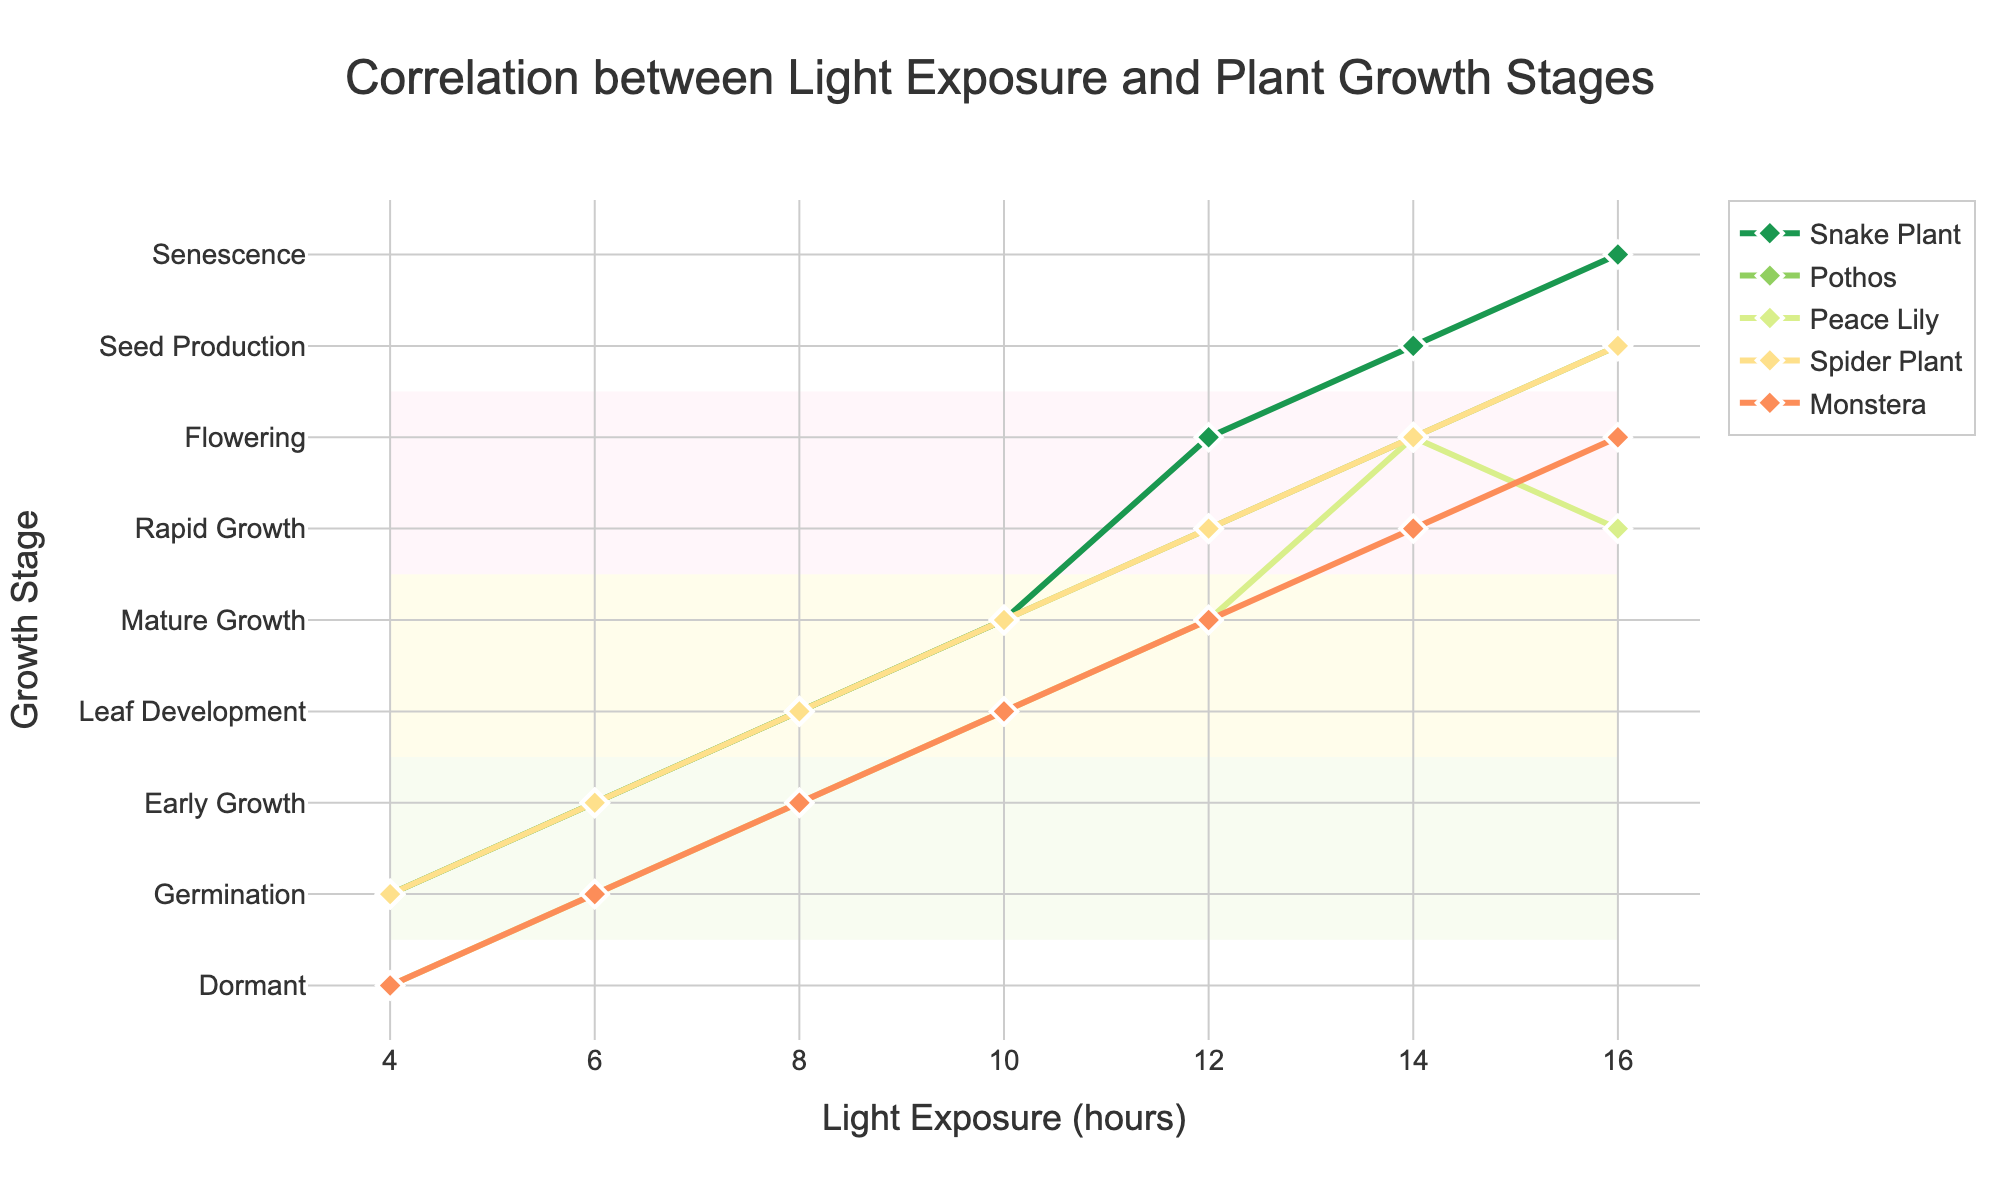What is the growth stage of the Snake Plant at 10 hours of light exposure? Refer to the line representing the Snake Plant at the 10-hour mark on the x-axis. The y-coordinate corresponds to "Mature Growth".
Answer: Mature Growth Which plant reached the "Flowering" stage first? Compare the light exposure durations where each plant reaches the "Flowering" stage. The Pothos reaches "Flowering" at 12 hours, ahead of other plants.
Answer: Pothos Between Snake Plant and Peace Lily, which plant reaches the "Seed Production" stage first? Check the light exposure duration at which both plants reach the "Seed Production" stage. The Snake Plant reaches it at 14 hours, while Peace Lily never reaches this stage.
Answer: Snake Plant During the "Leaf Development" stage, what is the range of light exposure hours for all plants? Look at the x-axis values for the points labeled "Leaf Development" across all plants. The range is from 8 to 10 hours.
Answer: 8 to 10 hours How do the growth stages of Monstera and Spider Plant compare at 16 hours of light exposure? At 16 hours, Monstera is at "Flowering" while Spider Plant is at "Seed Production", indicating Spider Plant is at a more advanced stage.
Answer: Monstera: Flowering, Spider Plant: Seed Production Which plant has the most varied growth stages across different light exposure hours? Evaluate how many different stages each plant goes through. The Snake Plant passes through several distinct stages: Germination, Early Growth, Leaf Development, Mature Growth, Flowering, Seed Production, and Senescence.
Answer: Snake Plant What happens to the growth stage of Peace Lily as light exposure moves from 12 to 14 hours? Observe the y-coordinates for Peace Lily at 12 and 14 hours. It moves from "Mature Growth" to "Flowering".
Answer: Shifts from Mature Growth to Flowering At 6 hours of light exposure, what stage are most plants in? Identify the stages for each plant at 6 hours. The majority of plants (Snake Plant, Pothos, and Spider Plant) are in the "Early Growth" stage.
Answer: Early Growth What is the color used to represent the rapid growth phase? Look at the background coloring of the rapid growth phase in the plot, which is highlighted with a specific color.
Answer: Yellow Which plant experiences the longest duration in the "Mature Growth" stage? Find the light exposure range where each plant is in "Mature Growth" and calculate the duration. The Snake Plant remains in the "Mature Growth" stage from 10 to 12 hours, making it the longest duration for this stage.
Answer: Snake Plant 